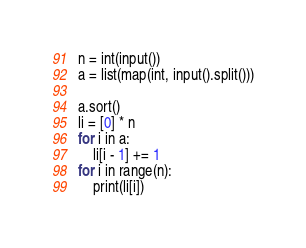<code> <loc_0><loc_0><loc_500><loc_500><_Python_>n = int(input())
a = list(map(int, input().split()))

a.sort()
li = [0] * n
for i in a:
    li[i - 1] += 1
for i in range(n):
    print(li[i])</code> 